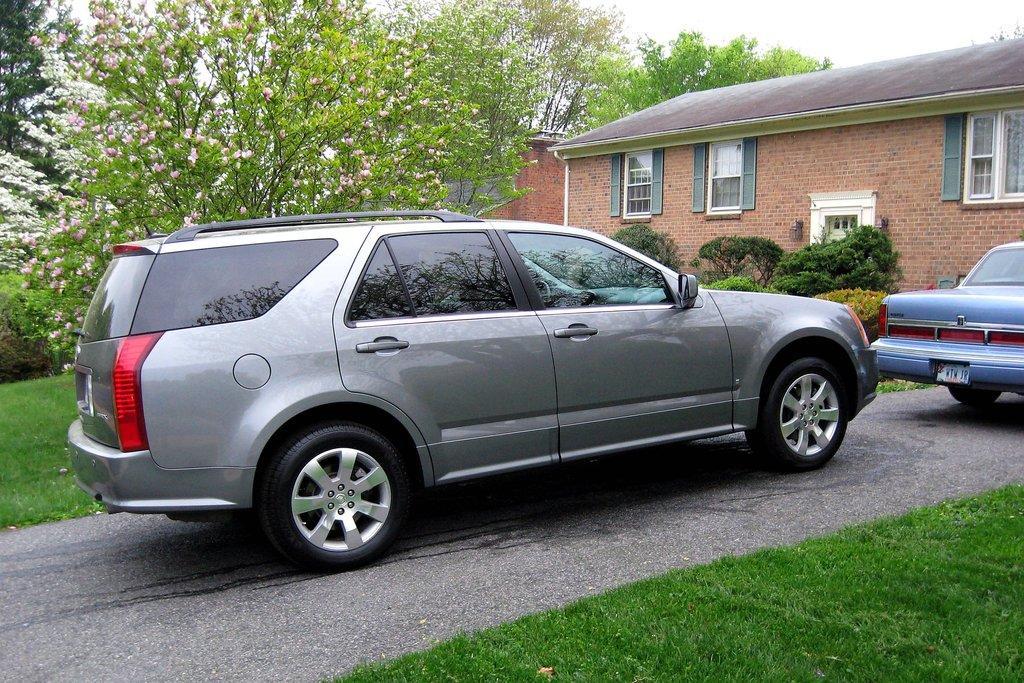How would you summarize this image in a sentence or two? In this image I can see a car on the road, on the right side there is a house. On the left side there are trees. 